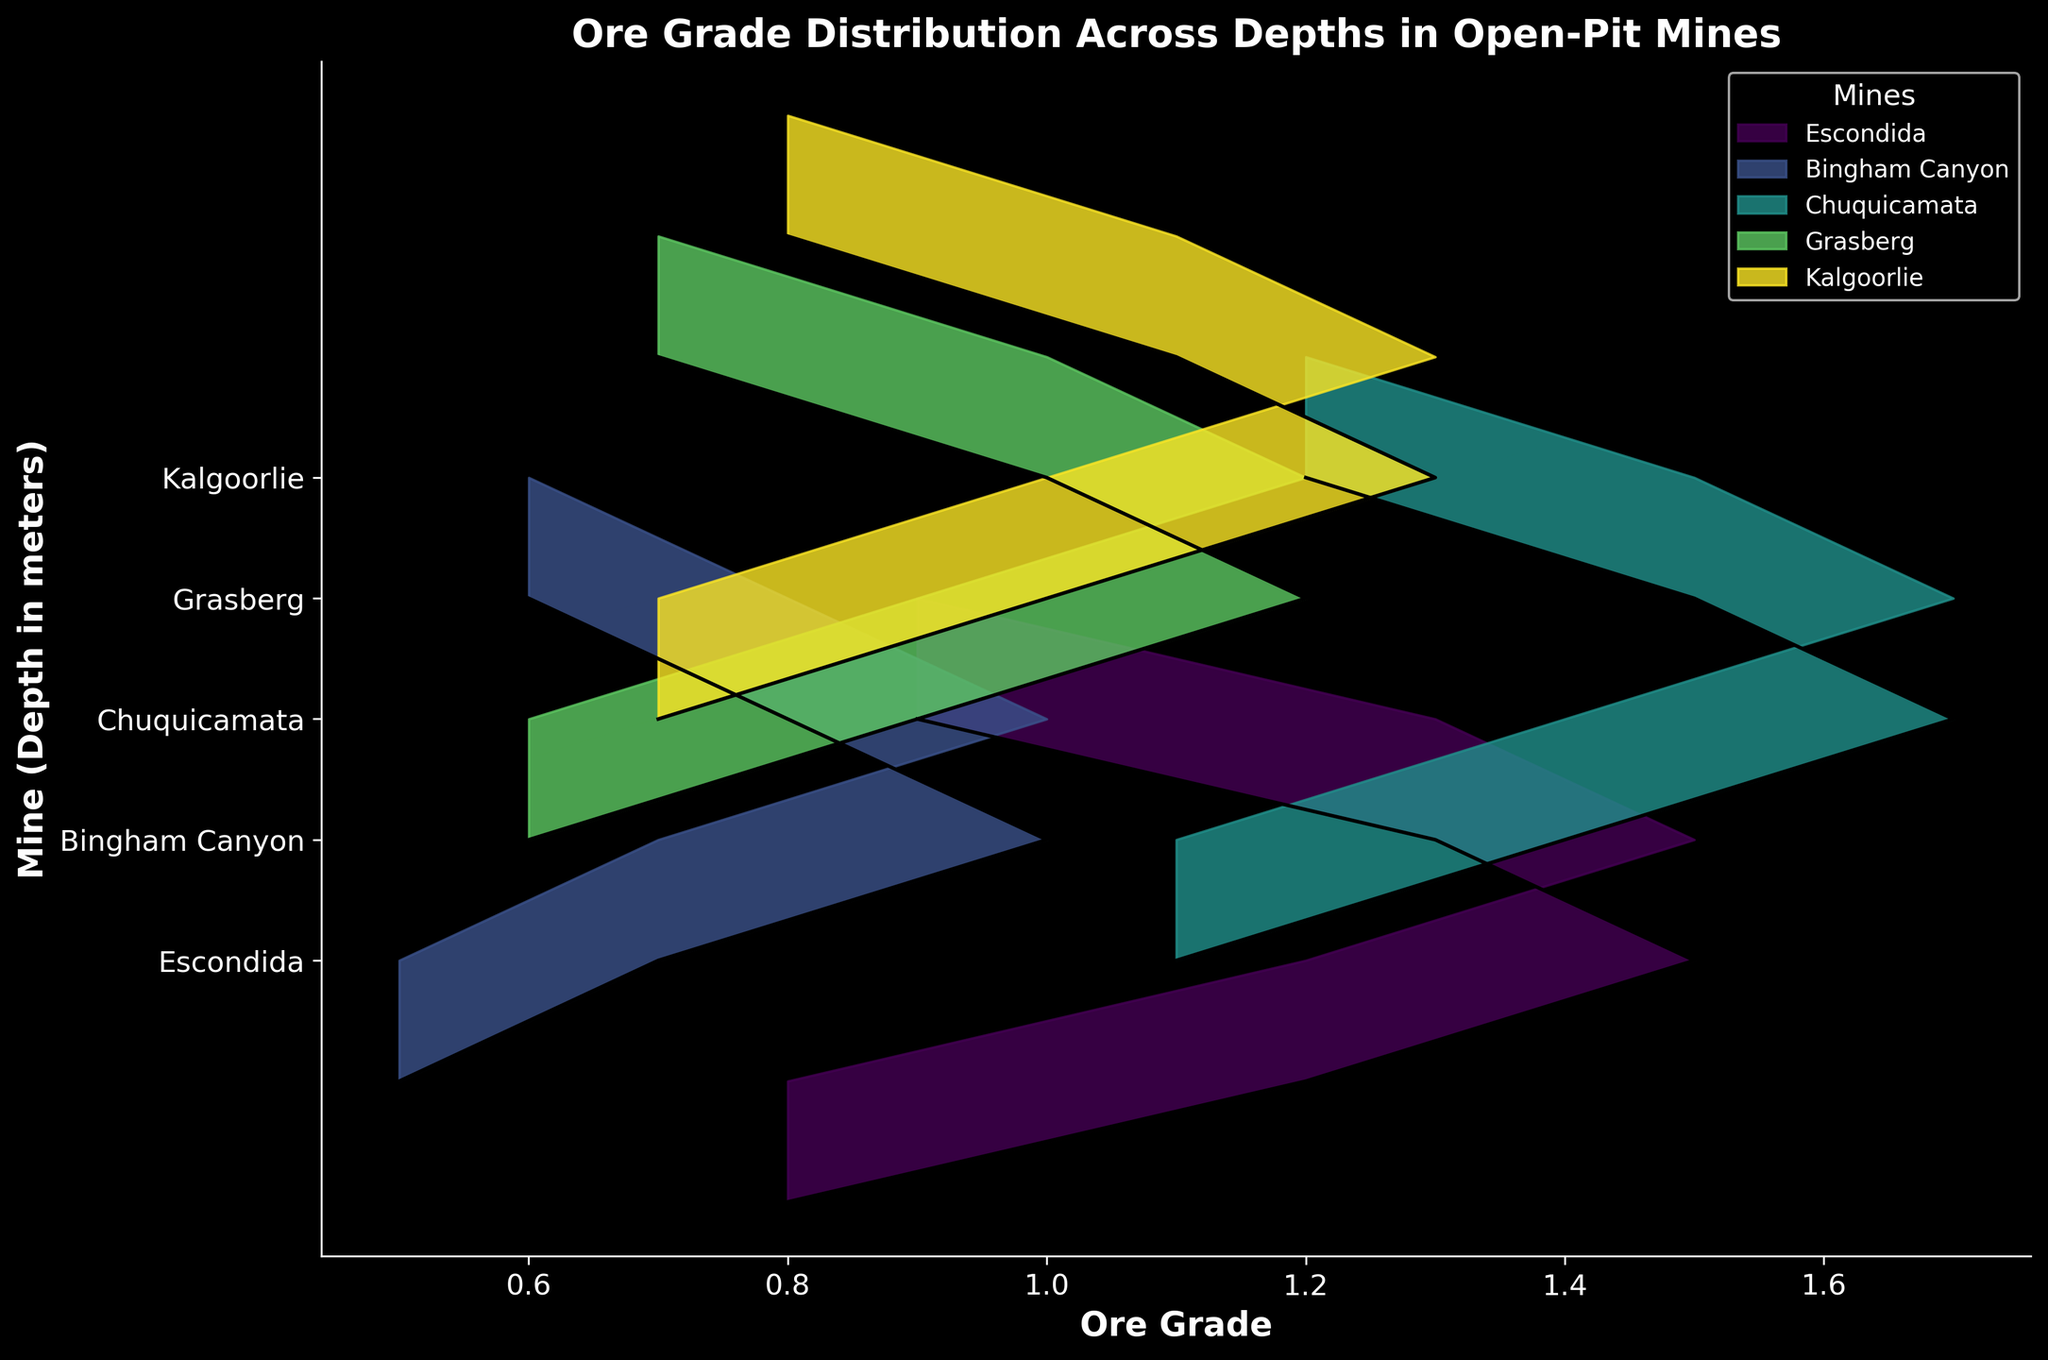what is the title of the figure? The title is usually placed at the top of the figure and describes what the figure is about. From the description provided, the title should be "Ore Grade Distribution Across Depths in Open-Pit Mines".
Answer: Ore Grade Distribution Across Depths in Open-Pit Mines What are the axes labels in the figure? The axes labels are located along the X-axis and Y-axis of the figure. According to the description, the X-axis is labeled "Ore Grade" and the Y-axis is labeled "Mine (Depth in meters)".
Answer: Ore Grade; Mine (Depth in meters) How many unique mines are represented in the figure? Each unique fill and line color combo represents a different mine. From the provided data, the mines are Escondida, Bingham Canyon, Chuquicamata, Grasberg, and Kalgoorlie. So, there are five unique mines.
Answer: 5 What is the ore grade at 100 meters depth for Chuquicamata? By checking the curve and values associated with Chuquicamata, at the point where the depth is 100 meters, the ore grade value is 1.7.
Answer: 1.7 Which mine shows the highest ore grade value at any depth? To determine the highest ore grade value overall, we should scan all displayed distributions. Chuquicamata at 100 meters depth shows the highest ore grade at 1.7.
Answer: Chuquicamata Compare the ore grade distribution between Escondida and Bingham Canyon at 50 meters depth. Which has a higher ore grade? By examining the segments corresponding to 50 meters for both Escondida and Bingham Canyon, the ore grade for Escondida is 1.2, while for Bingham Canyon it is 0.7. Escondida has a higher ore grade.
Answer: Escondida Which mine has the lowest ore grade at 150 meters depth? Checking the curves at the 150 meters depth, Bingham Canyon shows the lowest ore grade, which is 0.8.
Answer: Bingham Canyon What is the average ore grade for Grasberg across the displayed depths? The values for Grasberg at different depths are 0.6, 0.9, 1.2, 1.0, and 0.7. Adding these together gives 4.4, and the average is 4.4/5 = 0.88.
Answer: 0.88 For which depths does Kalgoorlie have an ore grade greater than 1.0? Scanning the Kalgoorlie distribution, the ore grade exceeds 1.0 at 50 meters (1.0), 100 meters (1.3), and 150 meters (1.1).
Answer: 100 meters, 150 meters Does any mine show a consistently increasing or decreasing ore grade with depth? By analyzing all distributions, it's observed that no single mine shows a consistently increasing or decreasing trend in ore grade with depth. The trends oscillate across different depths for all mines.
Answer: No 